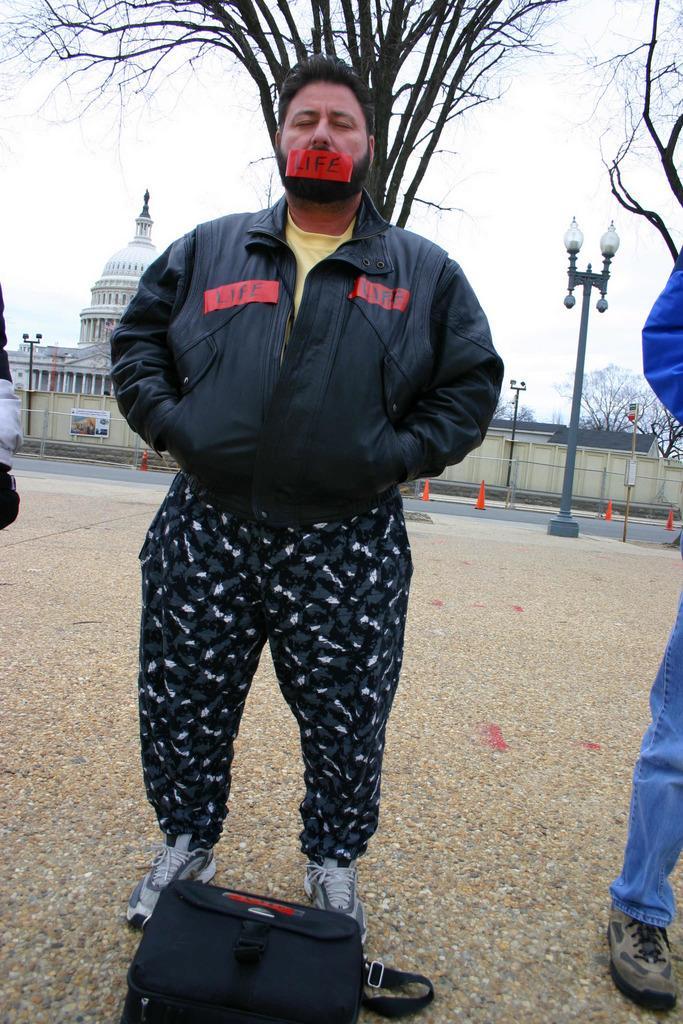Describe this image in one or two sentences. In this I can see a man wearing black color jacket, closing his eyes and standing on the road. In front of this man I can see a black color bag on the road. On the right side, I can see another person is also standing. In the background there is a building and trees and also I can see a road. On both sides of the road there are some poles. On the top of the image I can see the sky. 